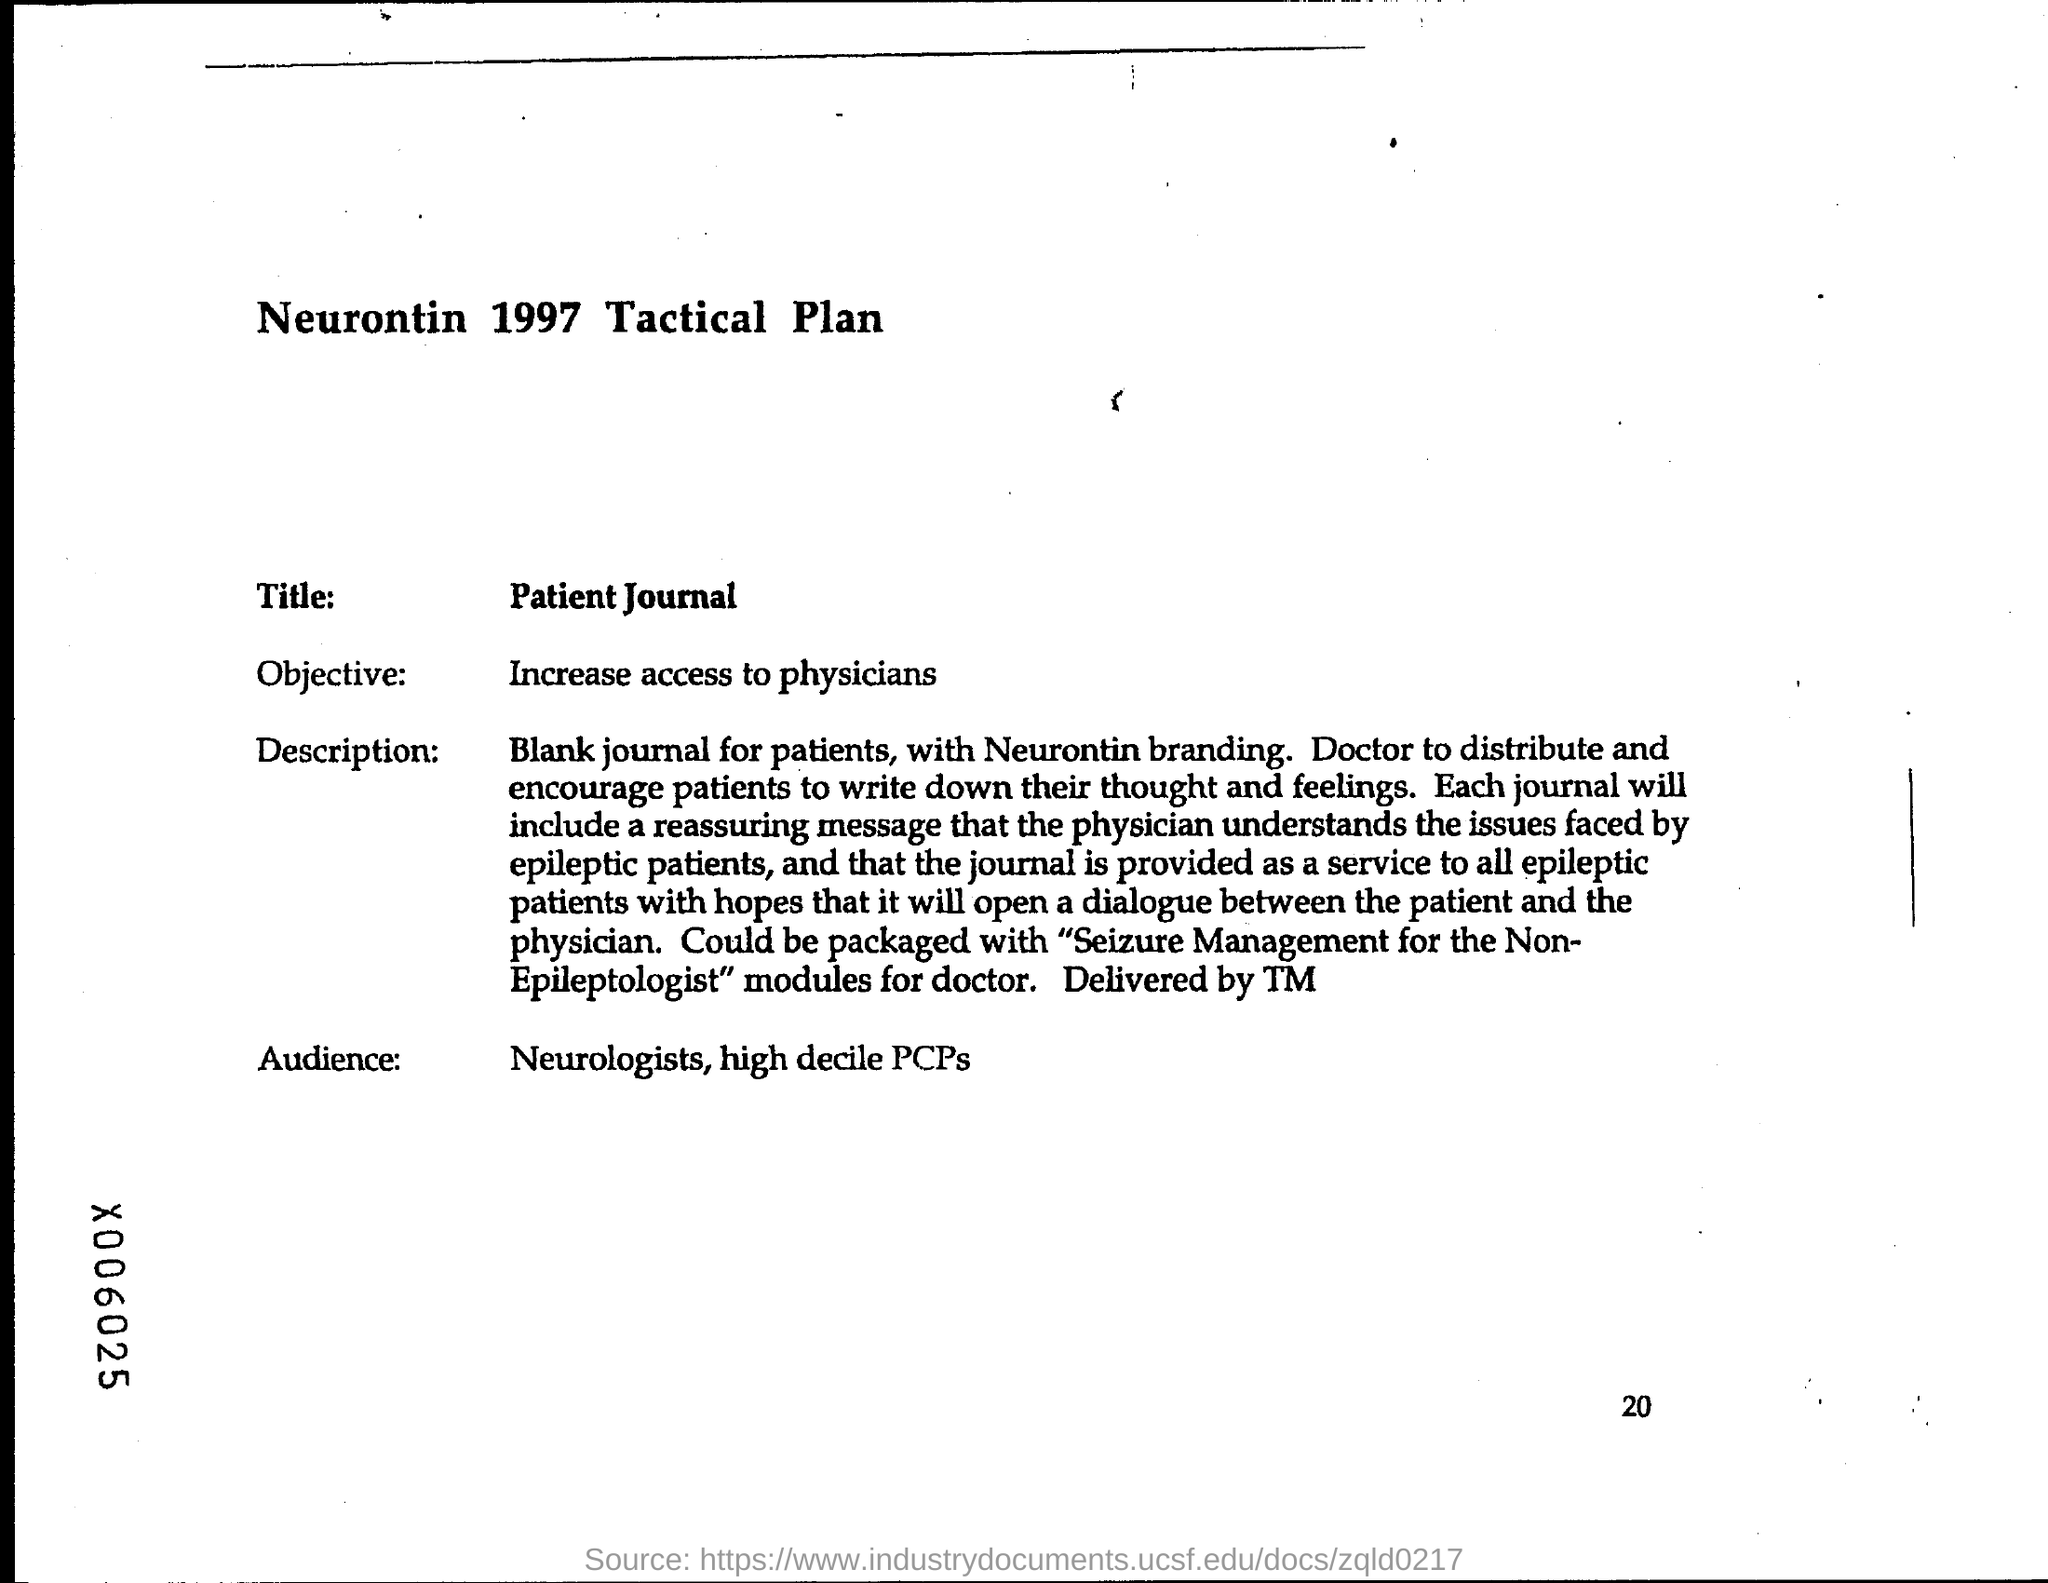What is the title ?
Your answer should be compact. Patient Journal. What is the objective ?
Ensure brevity in your answer.  Increase access to physicians. What is the page number at bottom of the page?
Keep it short and to the point. 20. 